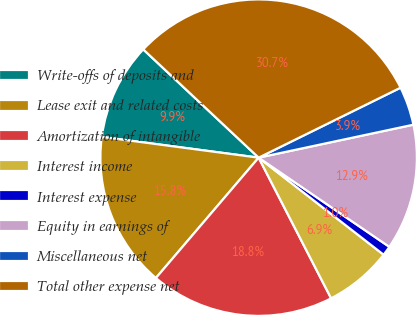Convert chart. <chart><loc_0><loc_0><loc_500><loc_500><pie_chart><fcel>Write-offs of deposits and<fcel>Lease exit and related costs<fcel>Amortization of intangible<fcel>Interest income<fcel>Interest expense<fcel>Equity in earnings of<fcel>Miscellaneous net<fcel>Total other expense net<nl><fcel>9.9%<fcel>15.85%<fcel>18.82%<fcel>6.92%<fcel>0.98%<fcel>12.87%<fcel>3.95%<fcel>30.72%<nl></chart> 